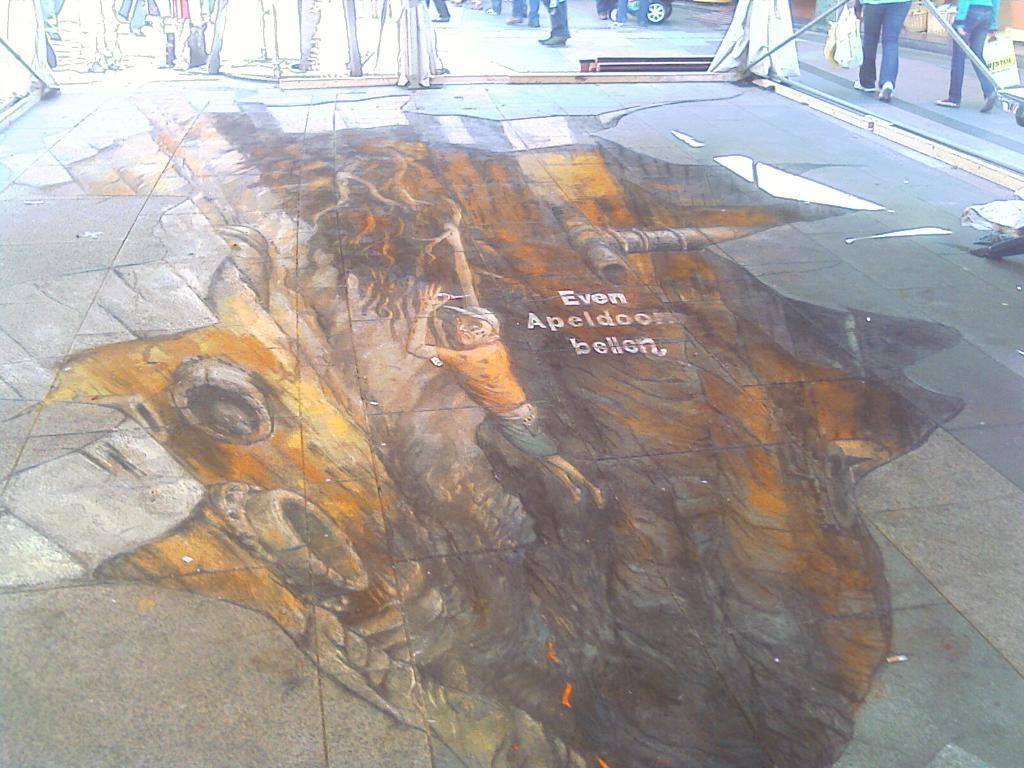What is the main subject of the image? The main subject of the image is a 3D painting on the floor. What can be seen in the background of the image? There are people walking in the background of the image. What are the chickens doing in the image? There are no chickens present in the image. 